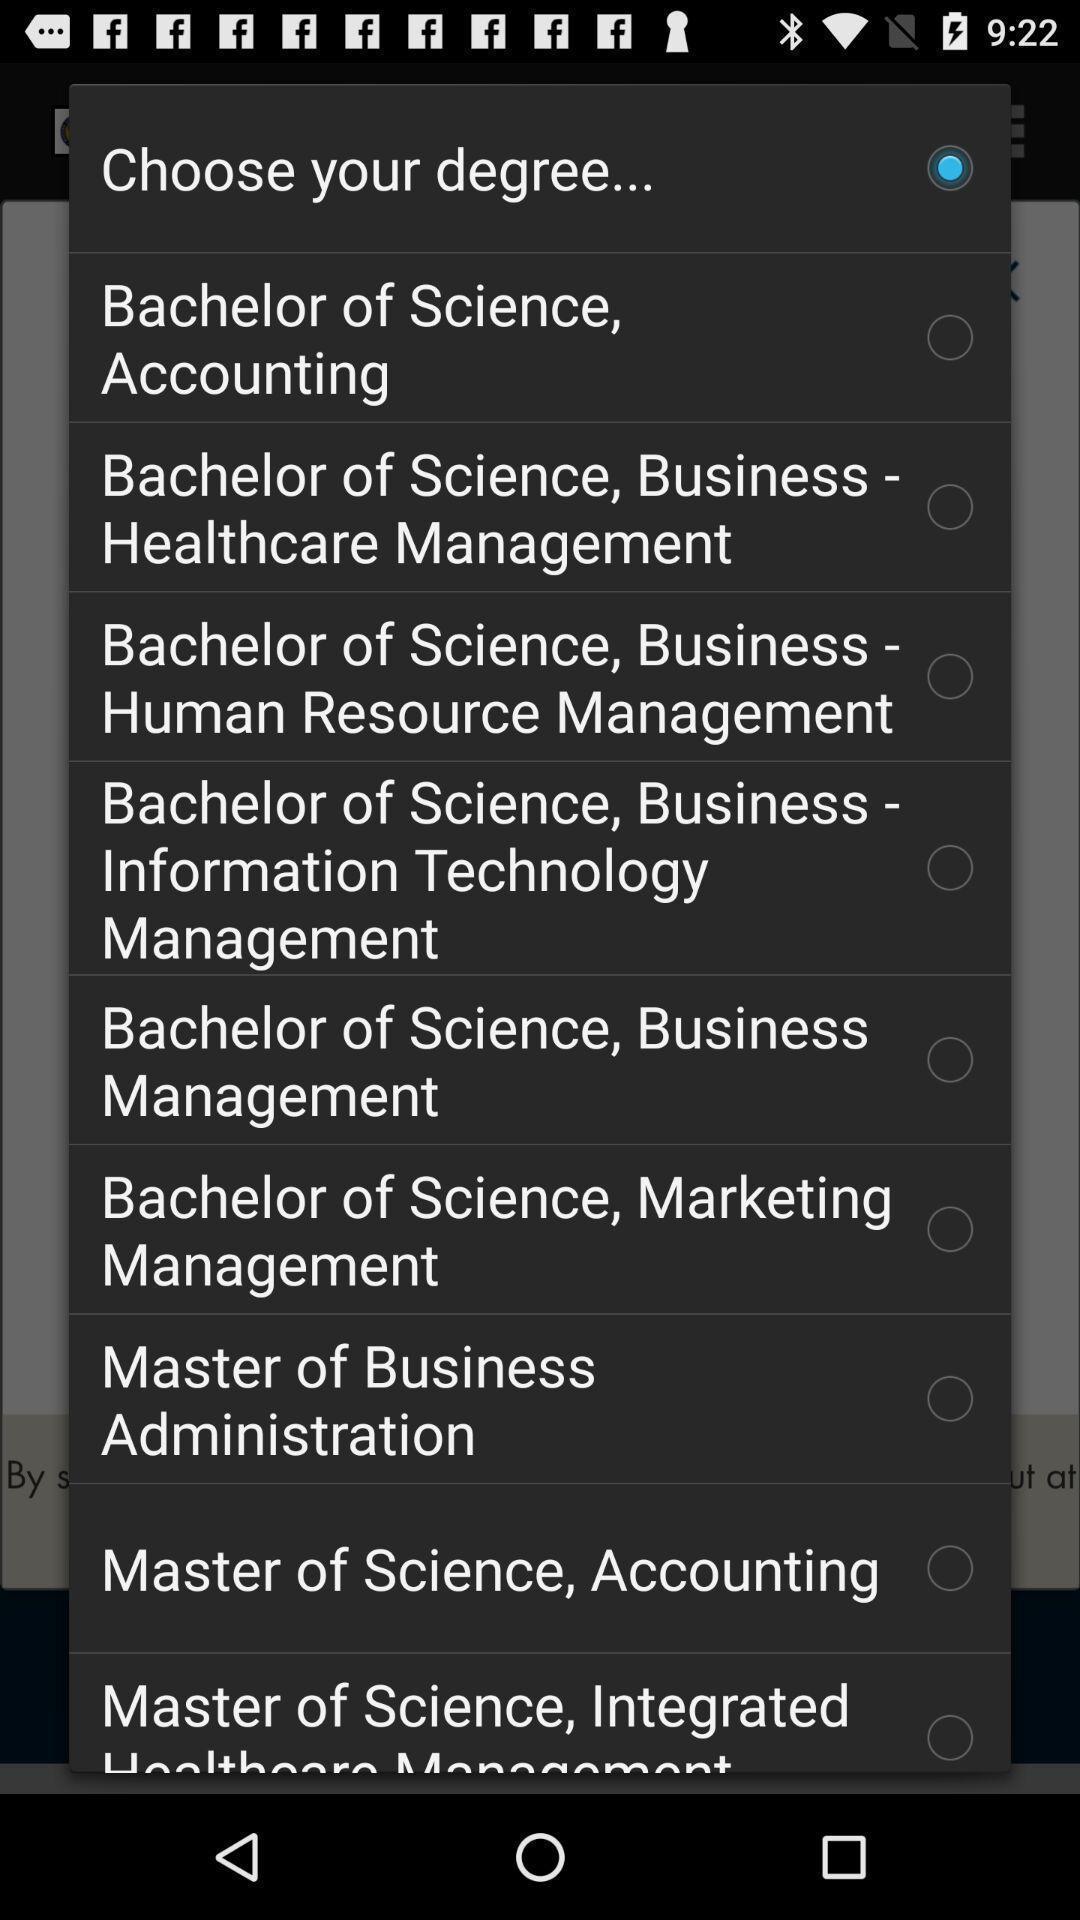What details can you identify in this image? Pop-up shows to choose your degree. 